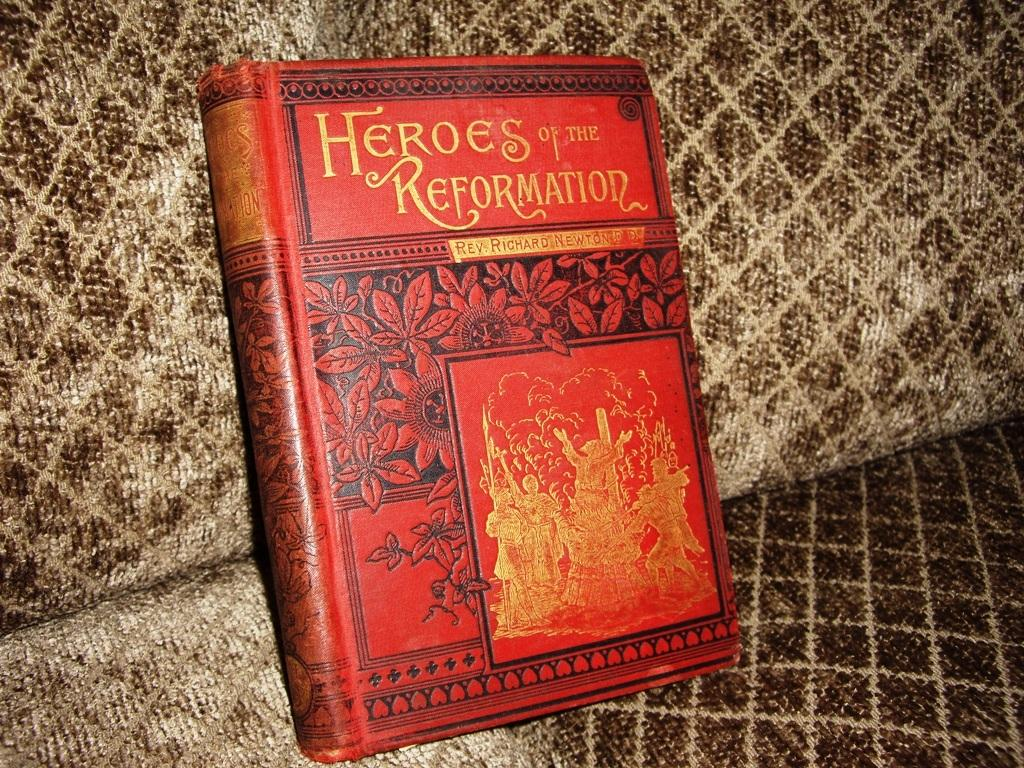<image>
Write a terse but informative summary of the picture. A book titled Heroes of the Reformation has a red cover with flowers. 